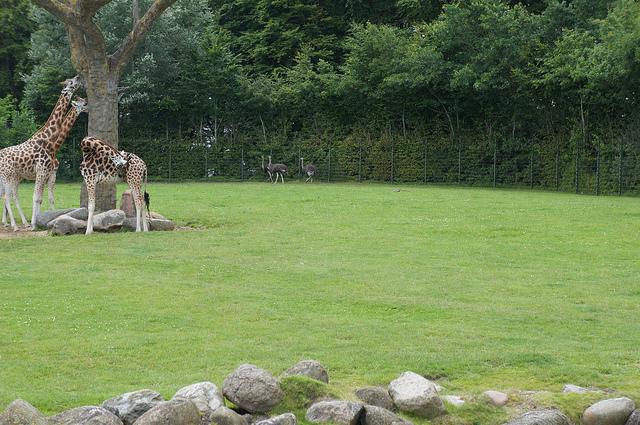Is this outdoors?
Answer briefly. Yes. Is this animal alone?
Be succinct. No. What is the young zebra doing?
Give a very brief answer. Grooming. How many animals are there?
Short answer required. 3. 